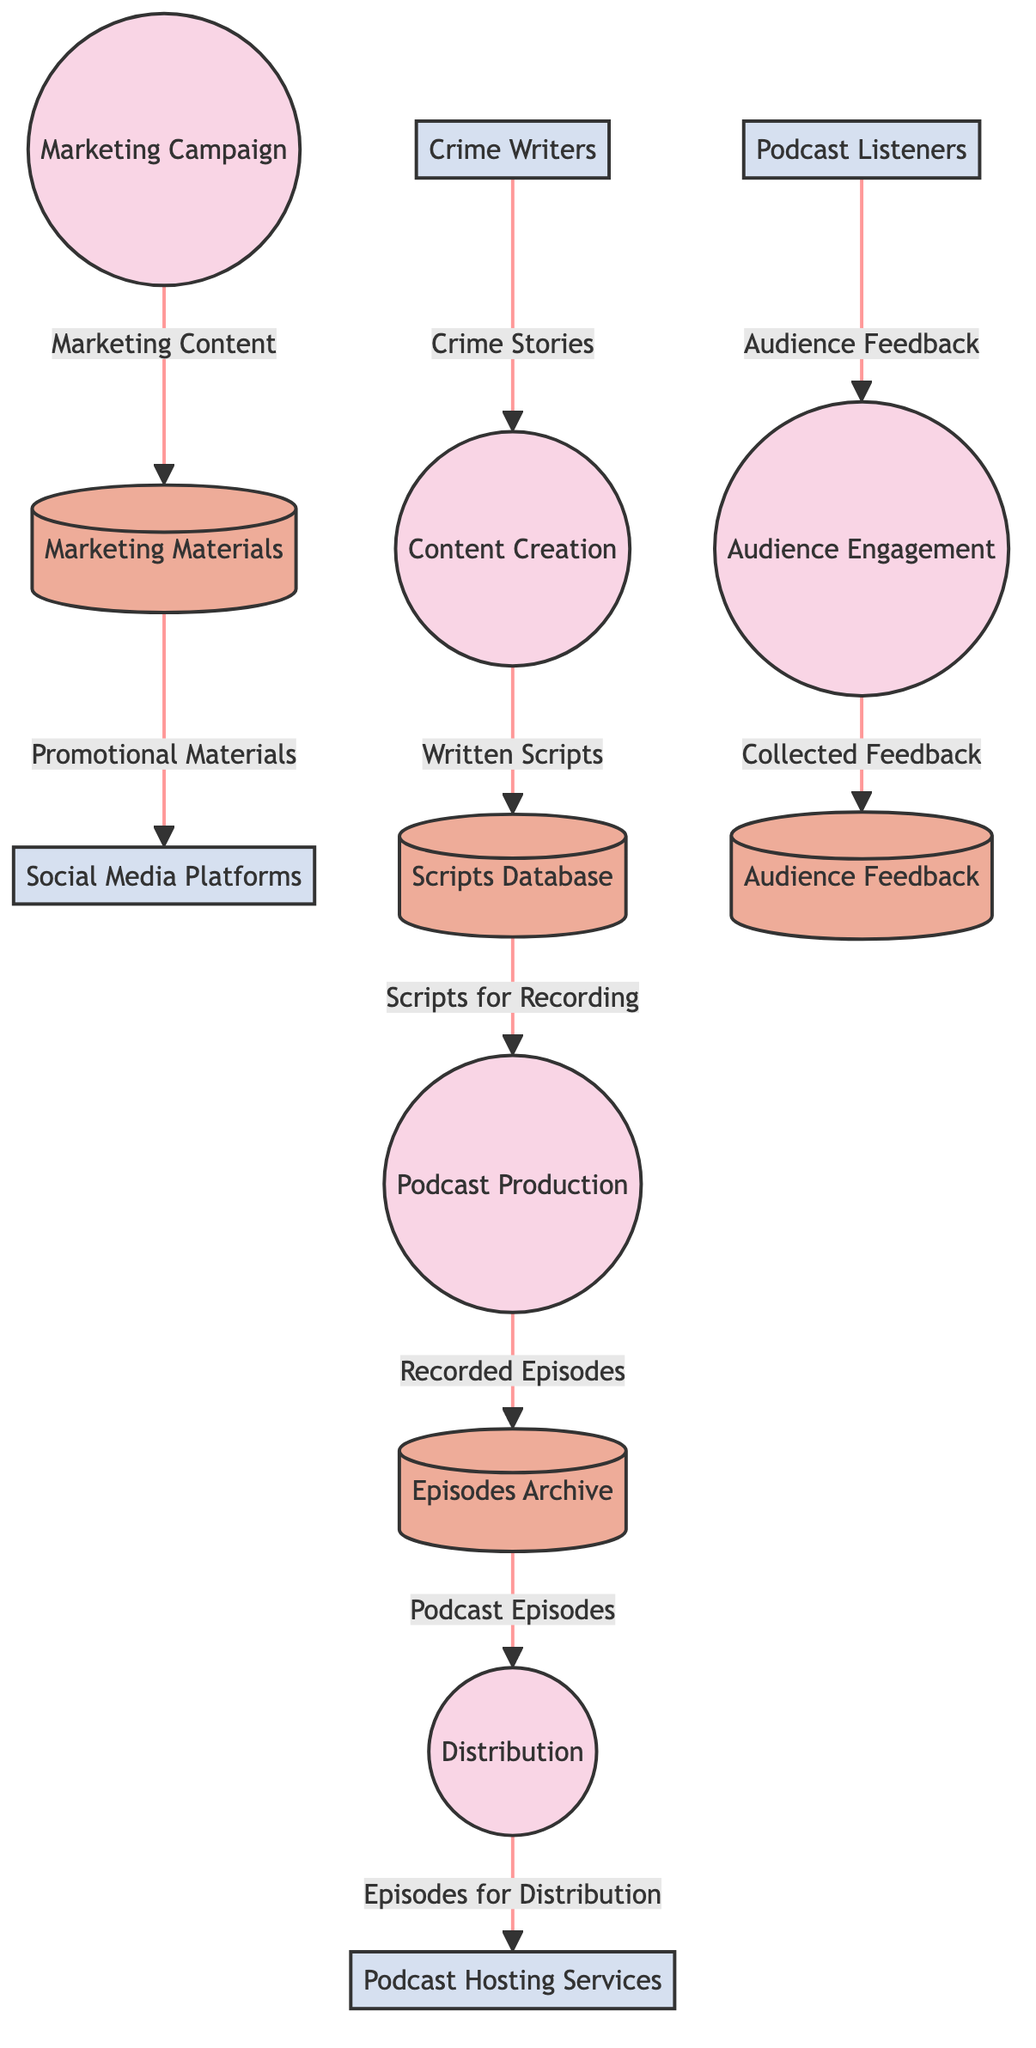What is the first process in the diagram? The first process in the diagram is "Content Creation," which is identified as process number 1.
Answer: Content Creation How many data stores are there? The diagram contains four data stores: "Scripts Database," "Episodes Archive," "Marketing Materials," and "Audience Feedback." Thus, the total count is four data stores.
Answer: 4 What data flows from Crime Writers to the first process? The data that flows from Crime Writers to the first process is "Crime Stories," as indicated by the flow connecting these two entities.
Answer: Crime Stories Which process is responsible for distributing podcast episodes? The process responsible for distributing podcast episodes is "Distribution," which is identified as process number 4 in the diagram.
Answer: Distribution What type of content does Marketing Campaign generate? The Marketing Campaign generates "Marketing Content," as shown by the data flow leading to the Marketing Materials data store.
Answer: Marketing Content Which data store receives audience feedback? The data store that receives audience feedback is "Audience Feedback," as indicated by the arrow from the Audience Engagement process flowing into this data store.
Answer: Audience Feedback How many external entities are connected to the processes? There are four external entities connected to the processes: "Crime Writers," "Podcast Hosting Services," "Social Media Platforms," and "Podcast Listeners." The total count of external entities is four.
Answer: 4 What is stored in the Episodes Archive? The Episodes Archive stores "Recorded Episodes," as indicated by the data flow from the Podcast Production process to this data store.
Answer: Recorded Episodes Which process utilizes feedback collected from the audience? The process that utilizes feedback collected from the audience is "Audience Engagement," as shown by its connection to the data flow from Podcast Listeners leading to this process.
Answer: Audience Engagement 